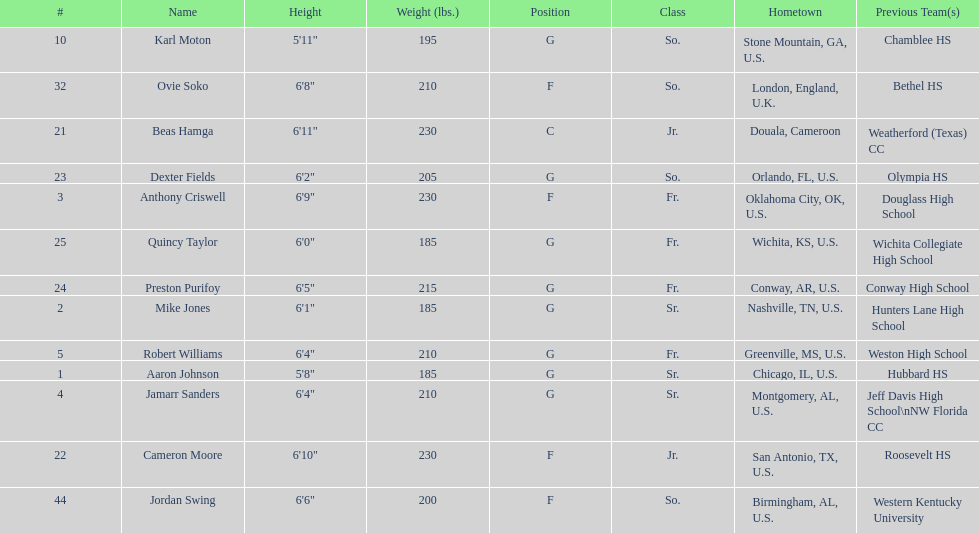Who is the tallest player on the team? Beas Hamga. I'm looking to parse the entire table for insights. Could you assist me with that? {'header': ['#', 'Name', 'Height', 'Weight (lbs.)', 'Position', 'Class', 'Hometown', 'Previous Team(s)'], 'rows': [['10', 'Karl Moton', '5\'11"', '195', 'G', 'So.', 'Stone Mountain, GA, U.S.', 'Chamblee HS'], ['32', 'Ovie Soko', '6\'8"', '210', 'F', 'So.', 'London, England, U.K.', 'Bethel HS'], ['21', 'Beas Hamga', '6\'11"', '230', 'C', 'Jr.', 'Douala, Cameroon', 'Weatherford (Texas) CC'], ['23', 'Dexter Fields', '6\'2"', '205', 'G', 'So.', 'Orlando, FL, U.S.', 'Olympia HS'], ['3', 'Anthony Criswell', '6\'9"', '230', 'F', 'Fr.', 'Oklahoma City, OK, U.S.', 'Douglass High School'], ['25', 'Quincy Taylor', '6\'0"', '185', 'G', 'Fr.', 'Wichita, KS, U.S.', 'Wichita Collegiate High School'], ['24', 'Preston Purifoy', '6\'5"', '215', 'G', 'Fr.', 'Conway, AR, U.S.', 'Conway High School'], ['2', 'Mike Jones', '6\'1"', '185', 'G', 'Sr.', 'Nashville, TN, U.S.', 'Hunters Lane High School'], ['5', 'Robert Williams', '6\'4"', '210', 'G', 'Fr.', 'Greenville, MS, U.S.', 'Weston High School'], ['1', 'Aaron Johnson', '5\'8"', '185', 'G', 'Sr.', 'Chicago, IL, U.S.', 'Hubbard HS'], ['4', 'Jamarr Sanders', '6\'4"', '210', 'G', 'Sr.', 'Montgomery, AL, U.S.', 'Jeff Davis High School\\nNW Florida CC'], ['22', 'Cameron Moore', '6\'10"', '230', 'F', 'Jr.', 'San Antonio, TX, U.S.', 'Roosevelt HS'], ['44', 'Jordan Swing', '6\'6"', '200', 'F', 'So.', 'Birmingham, AL, U.S.', 'Western Kentucky University']]} 